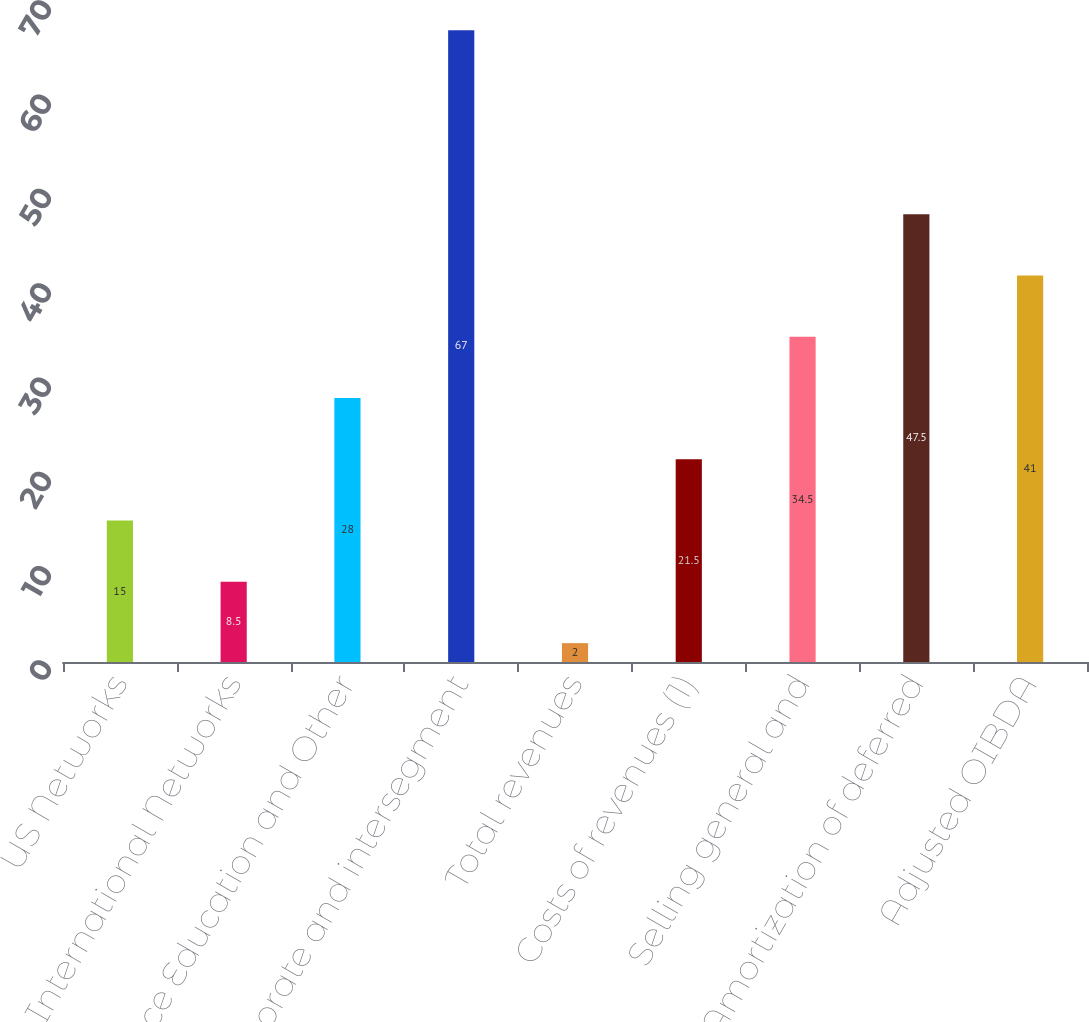<chart> <loc_0><loc_0><loc_500><loc_500><bar_chart><fcel>US Networks<fcel>International Networks<fcel>Commerce Education and Other<fcel>Corporate and intersegment<fcel>Total revenues<fcel>Costs of revenues (1)<fcel>Selling general and<fcel>Add Amortization of deferred<fcel>Adjusted OIBDA<nl><fcel>15<fcel>8.5<fcel>28<fcel>67<fcel>2<fcel>21.5<fcel>34.5<fcel>47.5<fcel>41<nl></chart> 